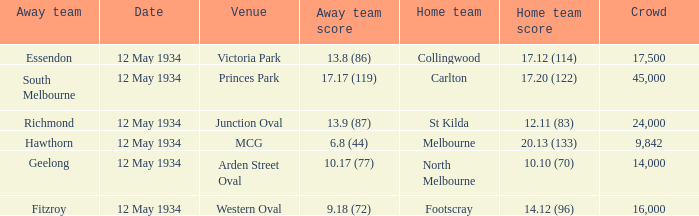What was the score of the away team while playing at the arden street oval? 10.17 (77). 